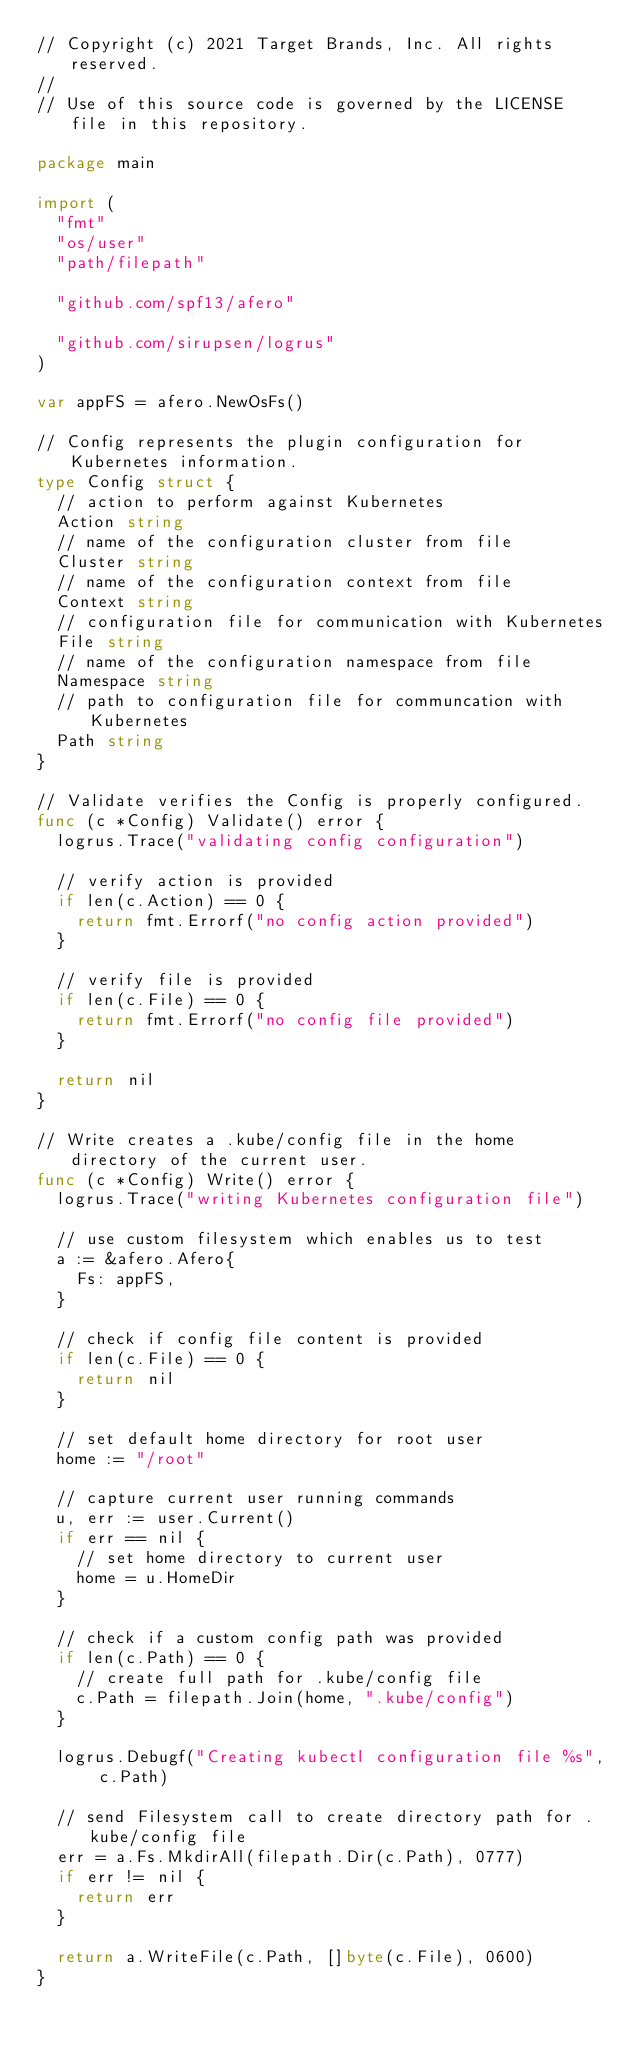<code> <loc_0><loc_0><loc_500><loc_500><_Go_>// Copyright (c) 2021 Target Brands, Inc. All rights reserved.
//
// Use of this source code is governed by the LICENSE file in this repository.

package main

import (
	"fmt"
	"os/user"
	"path/filepath"

	"github.com/spf13/afero"

	"github.com/sirupsen/logrus"
)

var appFS = afero.NewOsFs()

// Config represents the plugin configuration for Kubernetes information.
type Config struct {
	// action to perform against Kubernetes
	Action string
	// name of the configuration cluster from file
	Cluster string
	// name of the configuration context from file
	Context string
	// configuration file for communication with Kubernetes
	File string
	// name of the configuration namespace from file
	Namespace string
	// path to configuration file for communcation with Kubernetes
	Path string
}

// Validate verifies the Config is properly configured.
func (c *Config) Validate() error {
	logrus.Trace("validating config configuration")

	// verify action is provided
	if len(c.Action) == 0 {
		return fmt.Errorf("no config action provided")
	}

	// verify file is provided
	if len(c.File) == 0 {
		return fmt.Errorf("no config file provided")
	}

	return nil
}

// Write creates a .kube/config file in the home directory of the current user.
func (c *Config) Write() error {
	logrus.Trace("writing Kubernetes configuration file")

	// use custom filesystem which enables us to test
	a := &afero.Afero{
		Fs: appFS,
	}

	// check if config file content is provided
	if len(c.File) == 0 {
		return nil
	}

	// set default home directory for root user
	home := "/root"

	// capture current user running commands
	u, err := user.Current()
	if err == nil {
		// set home directory to current user
		home = u.HomeDir
	}

	// check if a custom config path was provided
	if len(c.Path) == 0 {
		// create full path for .kube/config file
		c.Path = filepath.Join(home, ".kube/config")
	}

	logrus.Debugf("Creating kubectl configuration file %s", c.Path)

	// send Filesystem call to create directory path for .kube/config file
	err = a.Fs.MkdirAll(filepath.Dir(c.Path), 0777)
	if err != nil {
		return err
	}

	return a.WriteFile(c.Path, []byte(c.File), 0600)
}
</code> 